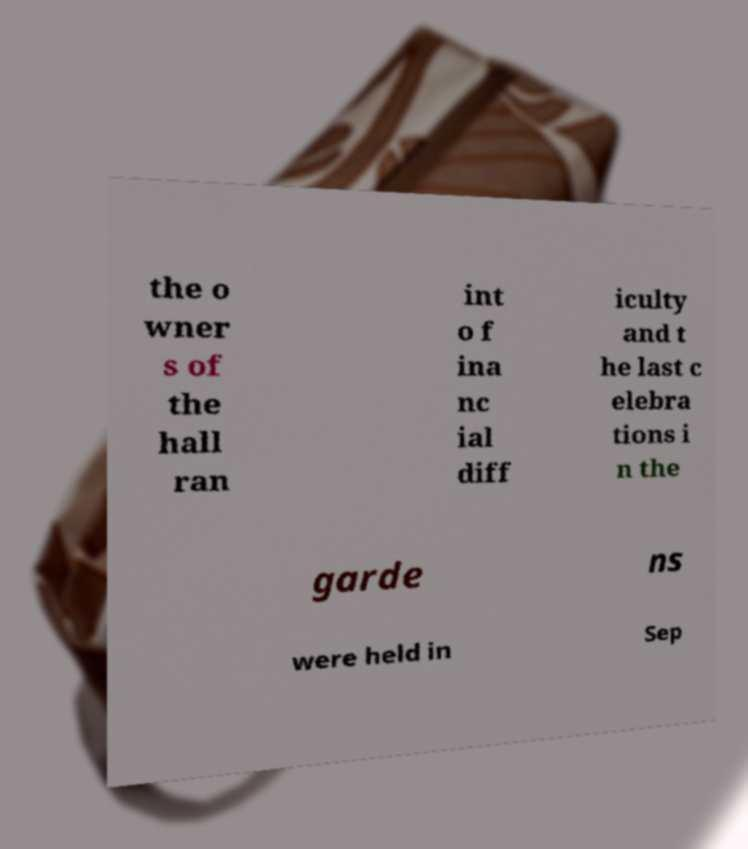Can you read and provide the text displayed in the image?This photo seems to have some interesting text. Can you extract and type it out for me? the o wner s of the hall ran int o f ina nc ial diff iculty and t he last c elebra tions i n the garde ns were held in Sep 